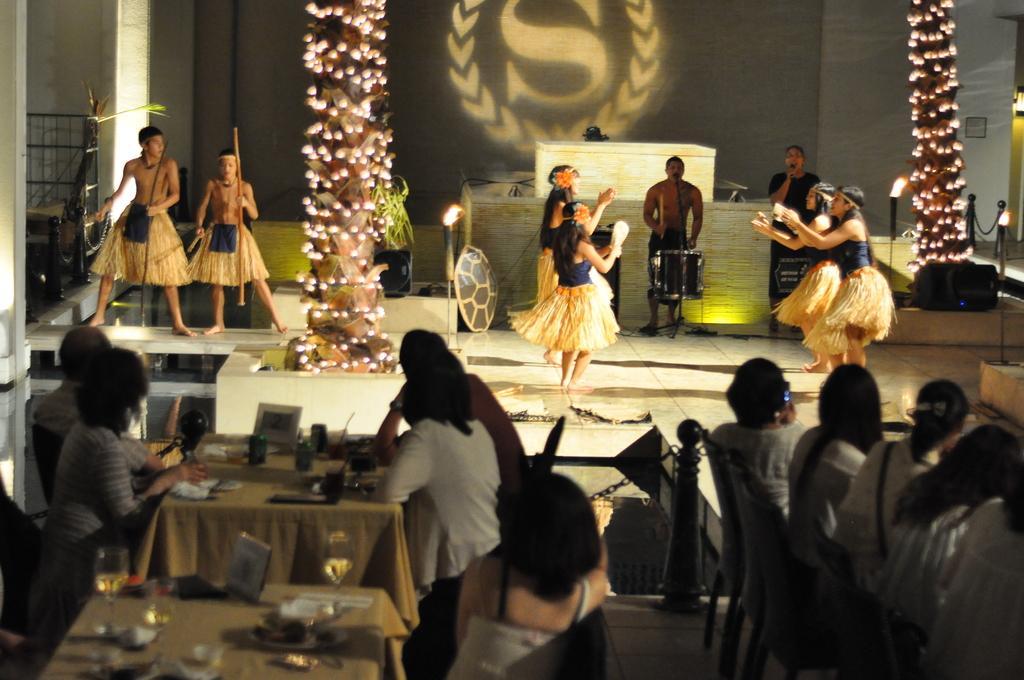Can you describe this image briefly? In this image I can see few people are sitting on the chairs. I can see few glasses and few objects on the tables. In the background I can see few people, lights, stairs, railing, wall and one person is standing in front of the drum and holding the stick. 